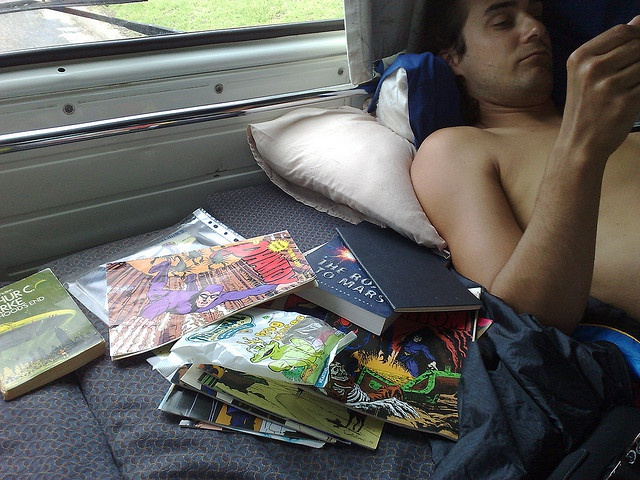Describe the objects in this image and their specific colors. I can see bed in lightgray, black, gray, and darkgray tones, people in lightgray, black, gray, and maroon tones, book in lightgray, black, white, darkgray, and gray tones, book in lightgray, darkgray, lightpink, and tan tones, and book in lightgray, darkgray, beige, and black tones in this image. 